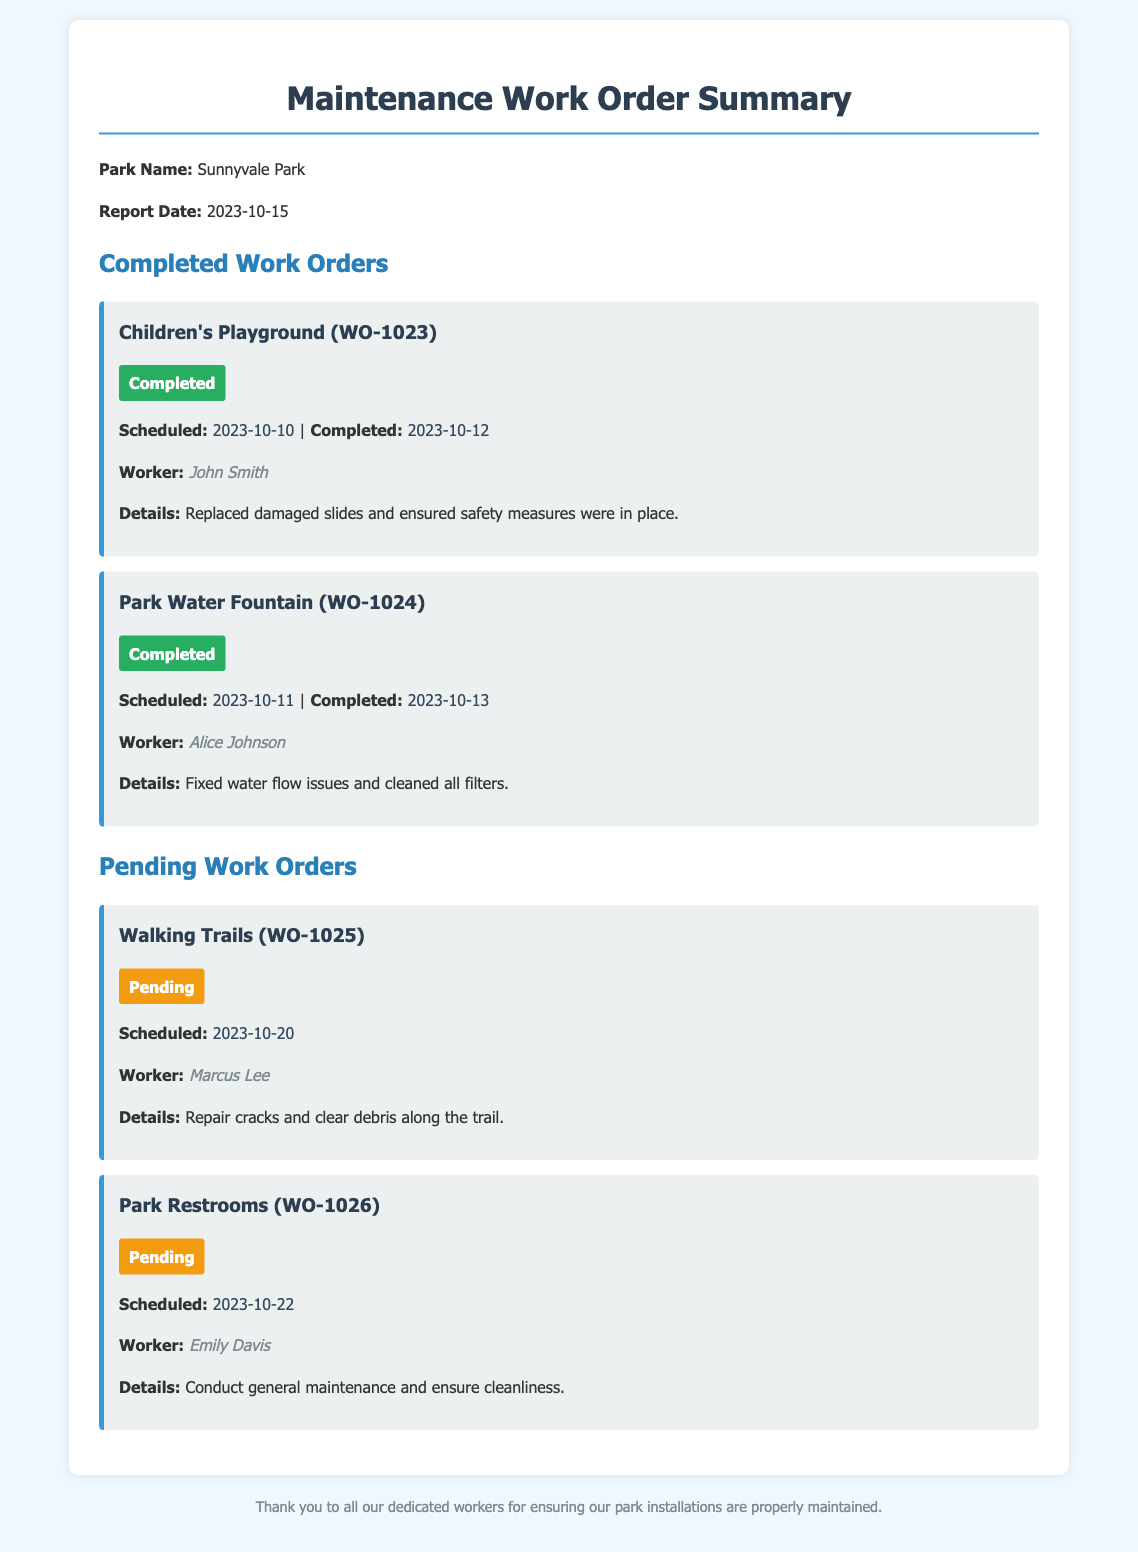what is the name of the park? The document specifies that the park name is Sunnyvale Park.
Answer: Sunnyvale Park what is the date of the report? The report date is explicitly mentioned in the document.
Answer: 2023-10-15 who completed the work on the Children's Playground? The worker who completed this task is listed in the document.
Answer: John Smith what is the completion status of the Park Water Fountain work order? The completion status is noted for each work order, including this one.
Answer: Completed when is the scheduled date for the Walking Trails repair? The scheduled date is provided for pending work orders.
Answer: 2023-10-20 how many completed work orders are there? Counting the completed work orders mentioned in the document gives this number.
Answer: 2 who is assigned to the Park Restrooms maintenance? The worker's name assigned to this task is mentioned in the document.
Answer: Emily Davis what is the primary task for the Park Water Fountain maintenance? The details section describes what work was performed.
Answer: Fixed water flow issues which work order is scheduled for the latest date? Evaluating all scheduled dates indicates which is the latest.
Answer: Park Restrooms 